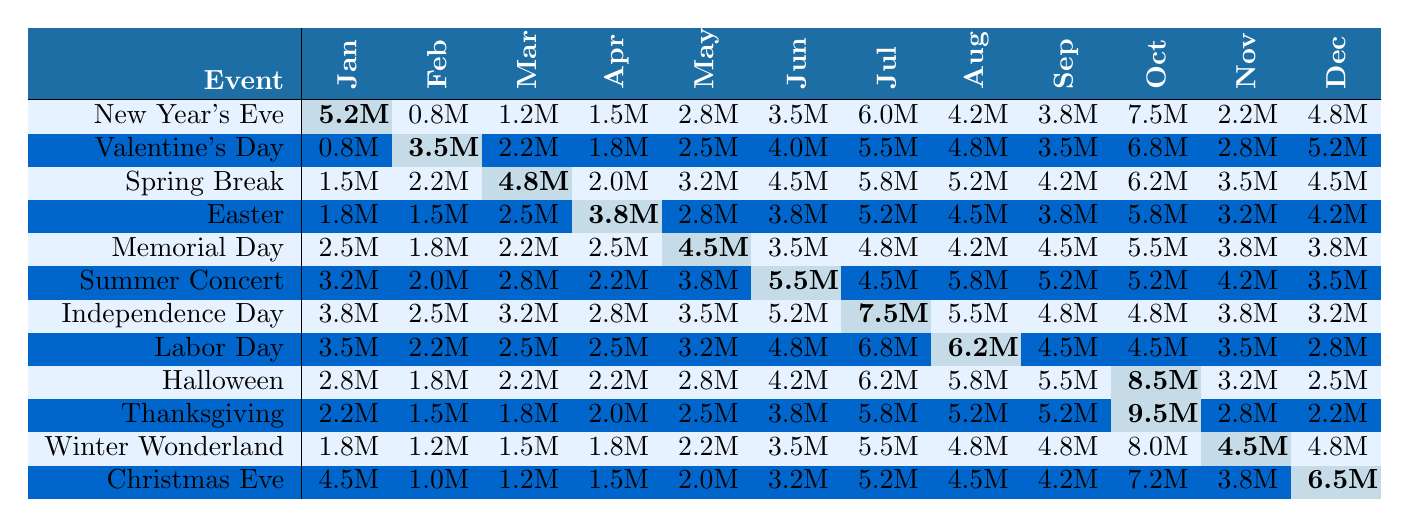What event generated the highest revenue in July? Looking at the table for July, the highest revenue is from the Independence Day Spectacular, which is 7.5M.
Answer: Independence Day Spectacular Which event had the lowest revenue in February? Under February, the lowest revenue is for New Year's Eve Extravaganza, which is 0.8M.
Answer: New Year's Eve Extravaganza What is the total revenue generated by Halloween Horror Nights throughout the year? Adding up the revenue for Halloween Horror Nights from all months: 2.8 + 1.8 + 2.2 + 2.2 + 2.8 + 4.2 + 6.2 + 5.8 + 5.5 + 8.5 + 3.2 + 2.5 = 47.0M.
Answer: 47.0M Which month had the highest total revenue across all events? By comparing the monthly revenues for each event in each month, October has the highest combined revenue of 57.0M from all events.
Answer: October Is the revenue for Valentine’s Day Romance always higher than Easter Eggstravaganza across the year? Checking the monthly revenues, Valentine's Day Romance has higher values in March, May, July, August, October, and December, but it is lower in January, February, April, June, September, and November. Therefore, it is not consistently higher.
Answer: No What is the average monthly revenue for the Summer Concert Series? To find the average, first sum the monthly revenues: 3.2 + 2.0 + 2.8 + 2.2 + 3.8 + 5.5 + 4.5 + 5.8 + 5.2 + 5.2 + 4.2 + 3.5 = 54.4M. Then divide by 12: 54.4M / 12 = 4.533M.
Answer: 4.533M How much more revenue did Thanksgiving Feast generate in October than in November? Looking at October, Thanksgiving Feast made 9.5M, and in November, it made 2.8M. The difference is 9.5M - 2.8M = 6.7M.
Answer: 6.7M Which event saw a decline in revenue from June to July? Reviewing the revenues for June and July, Memorial Day Weekend declined from 4.8M to 4.2M, and that is a decline.
Answer: Memorial Day Weekend Which two events had a close revenue of 5.8M in July? Observing the table, both Independence Day Spectacular and Labor Day Celebration had revenues of 5.8M in July.
Answer: Independence Day Spectacular and Labor Day Celebration What was the total revenue for the Christmas Eve Magic event from January to March? Adding up January (4.5M), February (1.0M), and March (1.2M) gives 4.5 + 1.0 + 1.2 = 6.7M.
Answer: 6.7M 